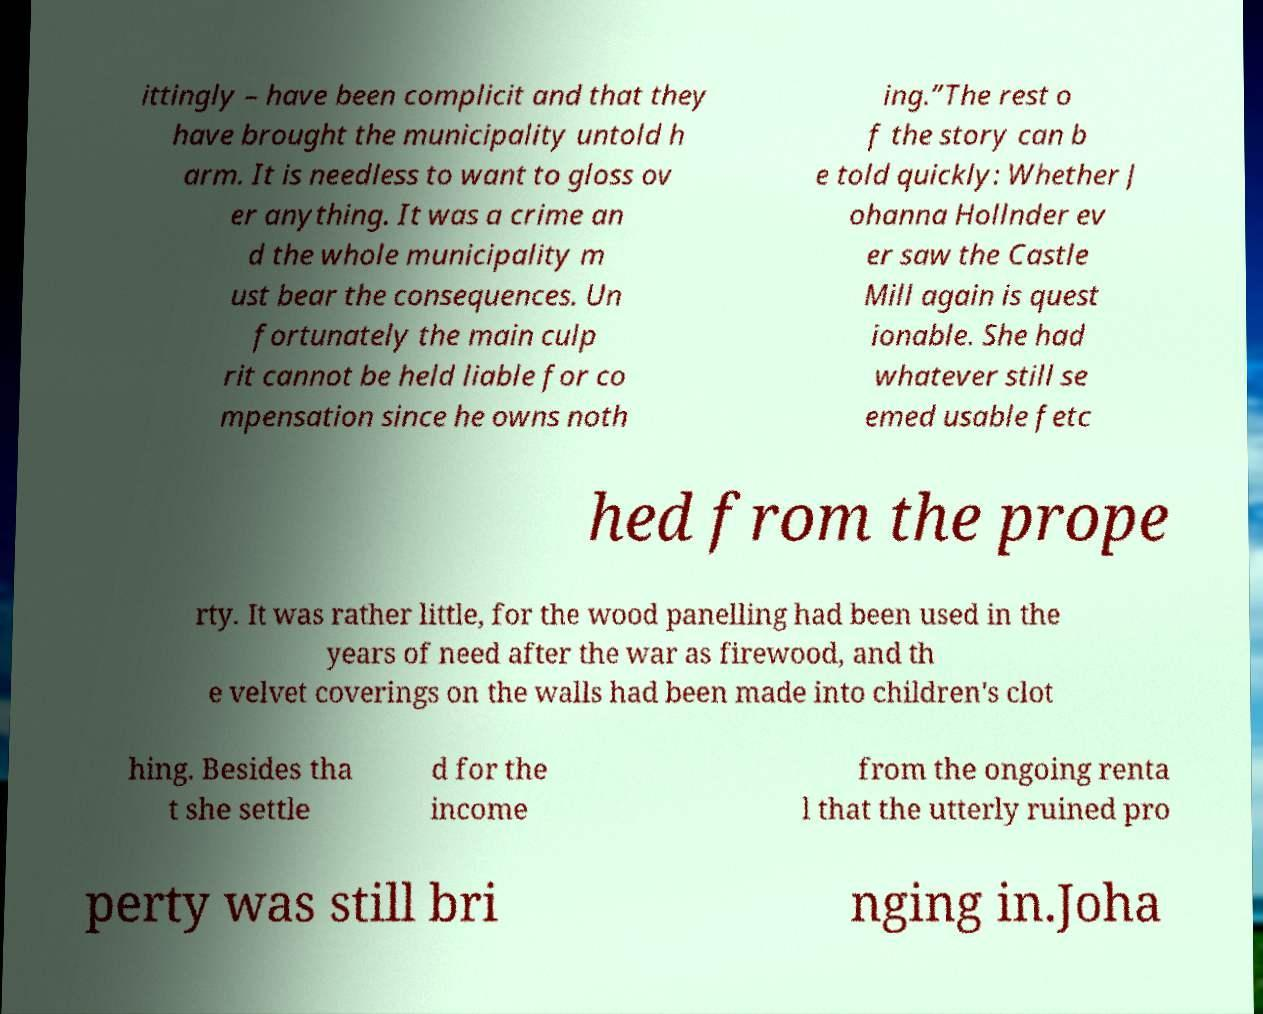Please identify and transcribe the text found in this image. ittingly – have been complicit and that they have brought the municipality untold h arm. It is needless to want to gloss ov er anything. It was a crime an d the whole municipality m ust bear the consequences. Un fortunately the main culp rit cannot be held liable for co mpensation since he owns noth ing.”The rest o f the story can b e told quickly: Whether J ohanna Hollnder ev er saw the Castle Mill again is quest ionable. She had whatever still se emed usable fetc hed from the prope rty. It was rather little, for the wood panelling had been used in the years of need after the war as firewood, and th e velvet coverings on the walls had been made into children's clot hing. Besides tha t she settle d for the income from the ongoing renta l that the utterly ruined pro perty was still bri nging in.Joha 